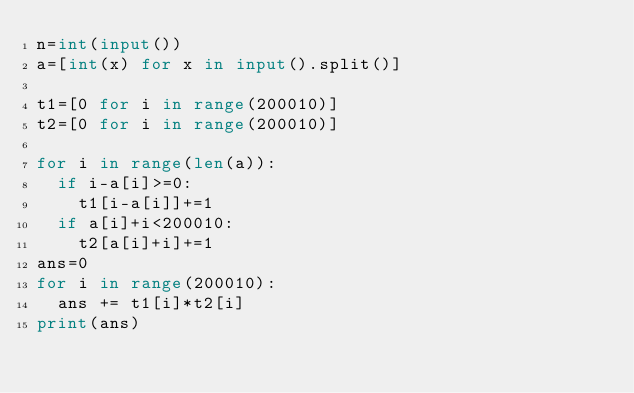<code> <loc_0><loc_0><loc_500><loc_500><_Python_>n=int(input())
a=[int(x) for x in input().split()]

t1=[0 for i in range(200010)]
t2=[0 for i in range(200010)]

for i in range(len(a)):
  if i-a[i]>=0:
    t1[i-a[i]]+=1
  if a[i]+i<200010:
    t2[a[i]+i]+=1
ans=0
for i in range(200010):
  ans += t1[i]*t2[i]
print(ans)</code> 